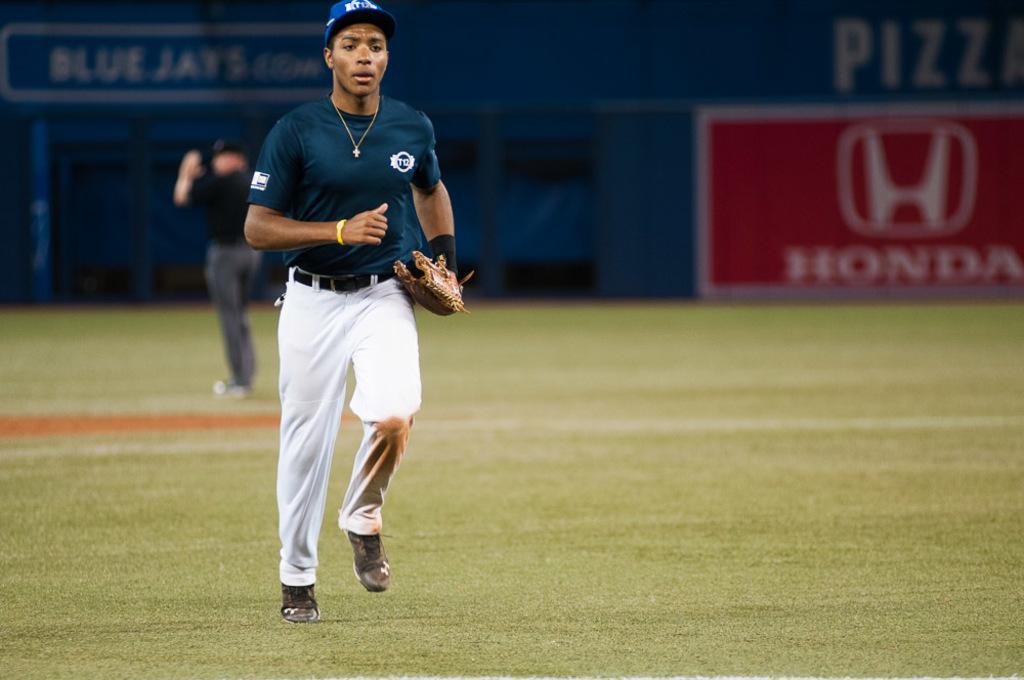What car company is on the outfield wall?
Keep it short and to the point. Honda. What team name is in the background?
Your response must be concise. Blue jays. 